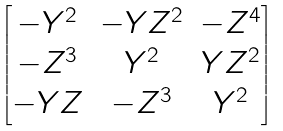<formula> <loc_0><loc_0><loc_500><loc_500>\begin{bmatrix} - Y ^ { 2 } & - Y Z ^ { 2 } & - Z ^ { 4 } \\ - Z ^ { 3 } & Y ^ { 2 } & Y Z ^ { 2 } \\ - Y Z & - Z ^ { 3 } & Y ^ { 2 } \\ \end{bmatrix}</formula> 